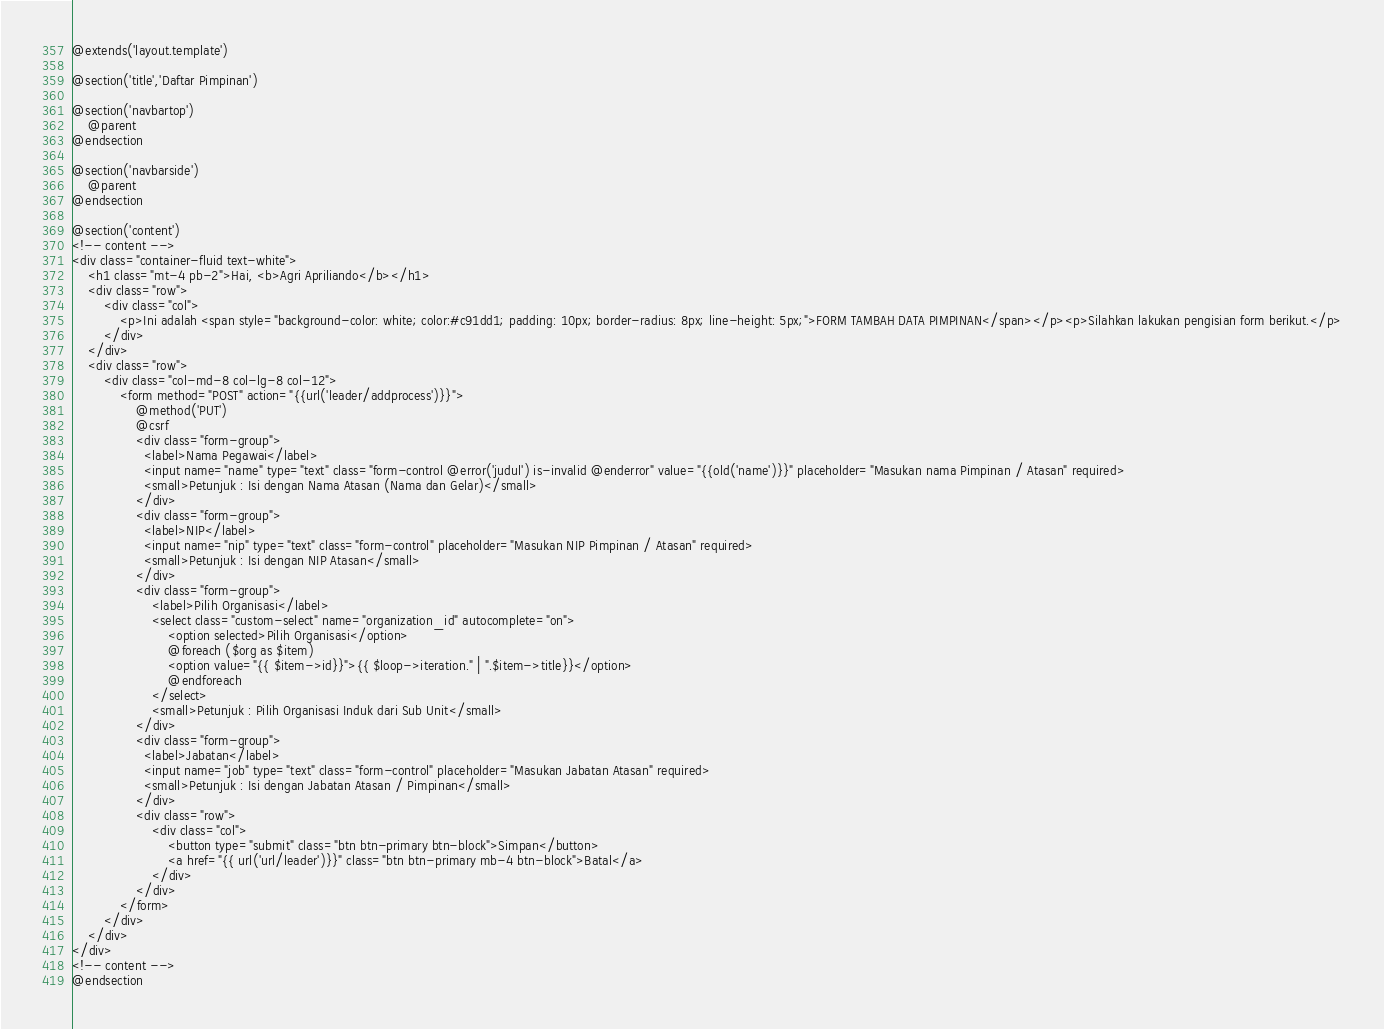Convert code to text. <code><loc_0><loc_0><loc_500><loc_500><_PHP_>@extends('layout.template')

@section('title','Daftar Pimpinan')

@section('navbartop')
    @parent
@endsection

@section('navbarside')
    @parent
@endsection

@section('content')
<!-- content -->
<div class="container-fluid text-white">
    <h1 class="mt-4 pb-2">Hai, <b>Agri Apriliando</b></h1>
    <div class="row">
        <div class="col">
            <p>Ini adalah <span style="background-color: white; color:#c91dd1; padding: 10px; border-radius: 8px; line-height: 5px;">FORM TAMBAH DATA PIMPINAN</span></p><p>Silahkan lakukan pengisian form berikut.</p>
        </div>
    </div>
    <div class="row">
        <div class="col-md-8 col-lg-8 col-12">
            <form method="POST" action="{{url('leader/addprocess')}}">
                @method('PUT')
                @csrf
                <div class="form-group">
                  <label>Nama Pegawai</label>
                  <input name="name" type="text" class="form-control @error('judul') is-invalid @enderror" value="{{old('name')}}" placeholder="Masukan nama Pimpinan / Atasan" required>
                  <small>Petunjuk : Isi dengan Nama Atasan (Nama dan Gelar)</small>
                </div>
                <div class="form-group">
                  <label>NIP</label>
                  <input name="nip" type="text" class="form-control" placeholder="Masukan NIP Pimpinan / Atasan" required>
                  <small>Petunjuk : Isi dengan NIP Atasan</small>
                </div>
                <div class="form-group">
                    <label>Pilih Organisasi</label>
                    <select class="custom-select" name="organization_id" autocomplete="on">
                        <option selected>Pilih Organisasi</option>
                        @foreach ($org as $item)
                        <option value="{{ $item->id}}">{{ $loop->iteration." | ".$item->title}}</option>
                        @endforeach
                    </select>
                    <small>Petunjuk : Pilih Organisasi Induk dari Sub Unit</small>
                </div>
                <div class="form-group">
                  <label>Jabatan</label>
                  <input name="job" type="text" class="form-control" placeholder="Masukan Jabatan Atasan" required>
                  <small>Petunjuk : Isi dengan Jabatan Atasan / Pimpinan</small>
                </div>
                <div class="row">
                    <div class="col">
                        <button type="submit" class="btn btn-primary btn-block">Simpan</button>
                        <a href="{{ url('url/leader')}}" class="btn btn-primary mb-4 btn-block">Batal</a>
                    </div>
                </div>
            </form>
        </div>
    </div>
</div>
<!-- content -->
@endsection</code> 